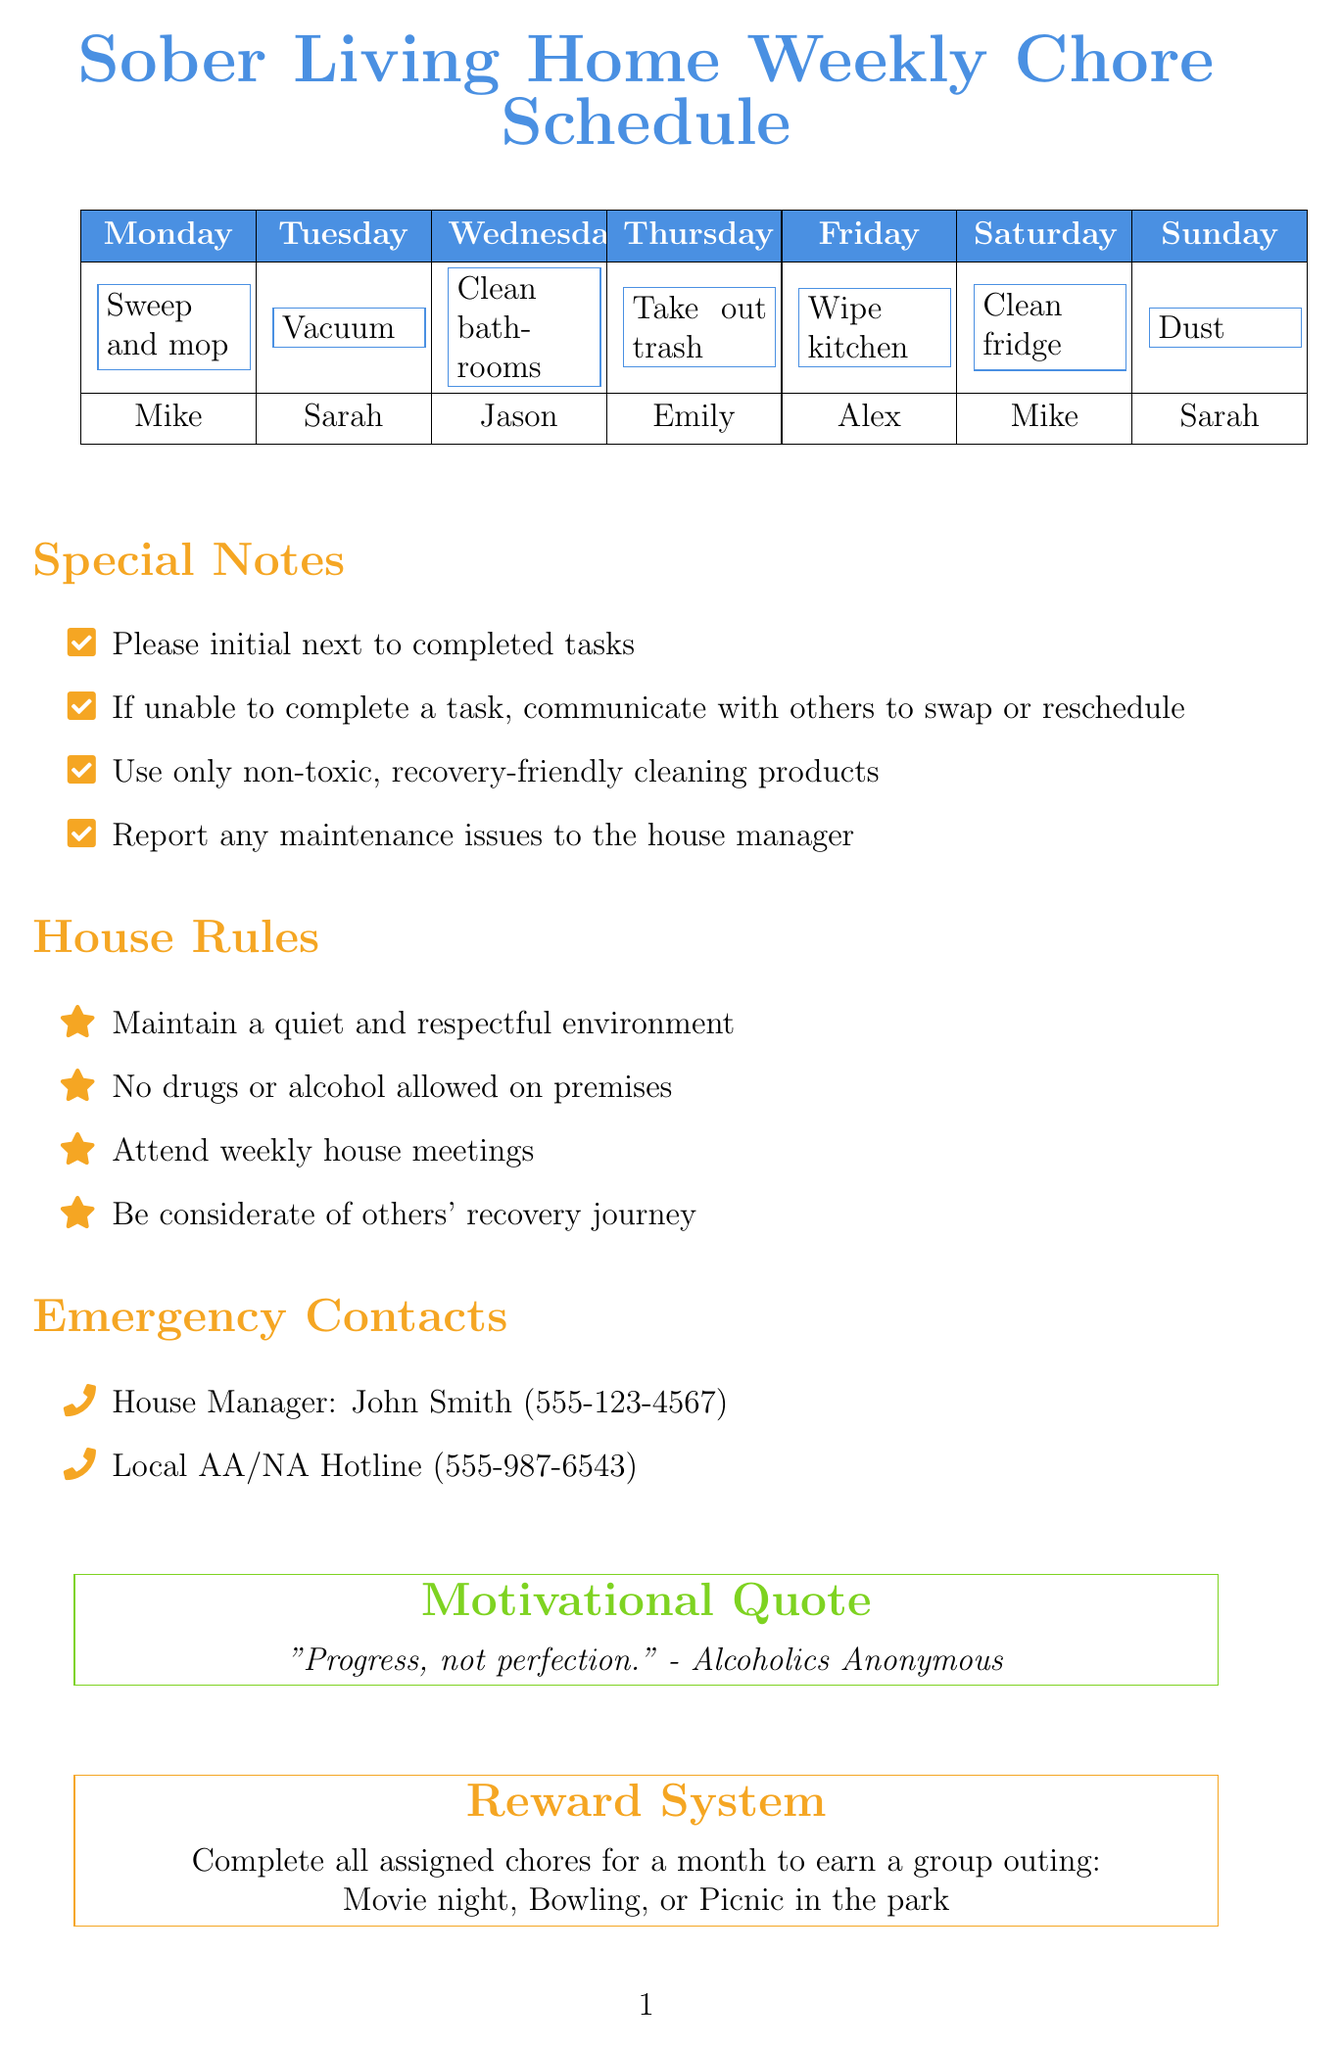what is the title of the document? The title is provided at the beginning of the document, indicating the purpose of the schedule for house chores.
Answer: Sober Living Home Weekly Chore Schedule who is assigned to clean the refrigerator on Friday? The assigned chores are laid out in a schedule format, making it easy to see who has which task each day.
Answer: Alex what is the emergency contact for the local AA/NA hotline? The document lists emergency contacts with their names and phone numbers, including the hotline.
Answer: 555-987-6543 what is the motivational quote included in the document? The document features a motivational quote aimed at encouraging the roommates in their recovery journey.
Answer: Progress, not perfection. - Alcoholics Anonymous how many housemates are there listed in the document? The number of housemates can be determined by counting the names listed under the roommates section.
Answer: 5 what is one of the special notes regarding task completion? Special notes detail expectations for roommates regarding their responsibilities and communication.
Answer: Please initial next to completed tasks what reward is given for completing all chores for a month? The document outlines a reward system for motivated participation in housekeeping efforts.
Answer: Group outing which day of the week is Jason assigned to clean bathrooms? The schedule assigns specific chores to each roommate on different days, including Jason's assignments.
Answer: Wednesday 